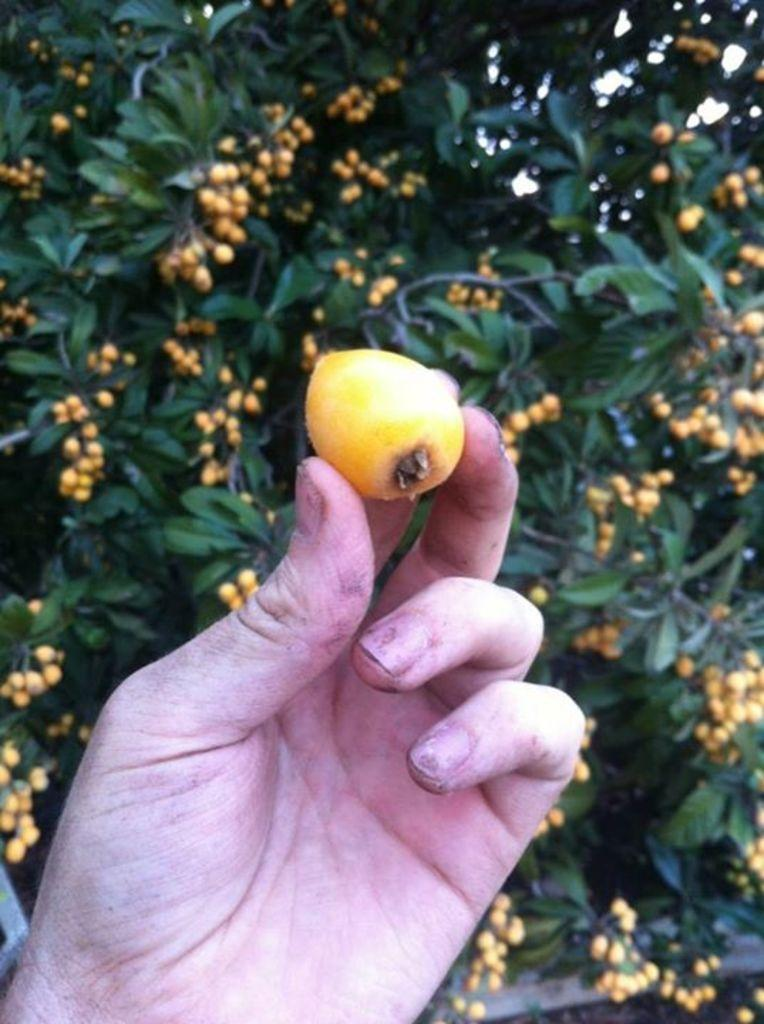What is the person's hand holding in the image? There is an object being held by the person's hand in the image. What can be seen in the background of the image? There are trees with fruits in the background of the image. What type of songs can be heard coming from the person's mind in the image? There is no indication in the image that the person's mind is producing songs, so it's not possible to determine what, if any, songs might be heard. 